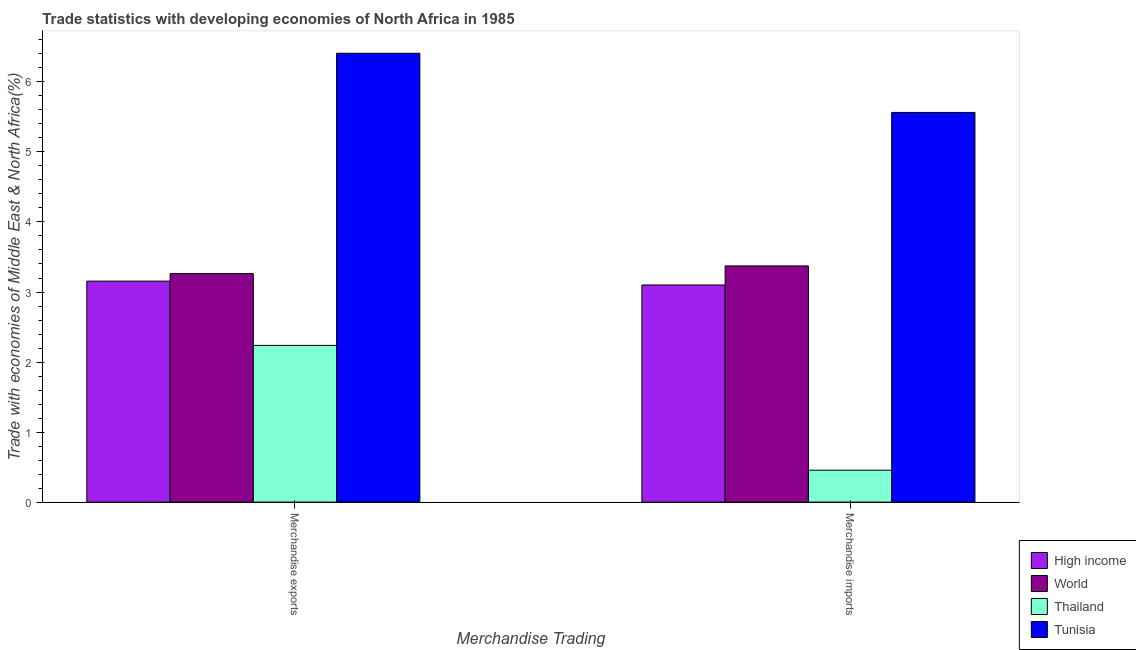Are the number of bars per tick equal to the number of legend labels?
Provide a short and direct response. Yes. Are the number of bars on each tick of the X-axis equal?
Offer a terse response. Yes. How many bars are there on the 1st tick from the left?
Provide a short and direct response. 4. How many bars are there on the 2nd tick from the right?
Keep it short and to the point. 4. What is the merchandise exports in High income?
Make the answer very short. 3.16. Across all countries, what is the maximum merchandise exports?
Your response must be concise. 6.41. Across all countries, what is the minimum merchandise imports?
Provide a short and direct response. 0.46. In which country was the merchandise exports maximum?
Provide a succinct answer. Tunisia. In which country was the merchandise imports minimum?
Make the answer very short. Thailand. What is the total merchandise imports in the graph?
Offer a terse response. 12.49. What is the difference between the merchandise exports in Thailand and that in Tunisia?
Your answer should be very brief. -4.17. What is the difference between the merchandise exports in Thailand and the merchandise imports in High income?
Ensure brevity in your answer.  -0.86. What is the average merchandise exports per country?
Provide a succinct answer. 3.77. What is the difference between the merchandise exports and merchandise imports in World?
Give a very brief answer. -0.11. What is the ratio of the merchandise exports in World to that in Tunisia?
Ensure brevity in your answer.  0.51. Is the merchandise exports in Tunisia less than that in High income?
Your answer should be very brief. No. What does the 1st bar from the right in Merchandise imports represents?
Keep it short and to the point. Tunisia. How many bars are there?
Make the answer very short. 8. How many countries are there in the graph?
Provide a succinct answer. 4. Does the graph contain any zero values?
Make the answer very short. No. How many legend labels are there?
Offer a terse response. 4. How are the legend labels stacked?
Offer a terse response. Vertical. What is the title of the graph?
Offer a very short reply. Trade statistics with developing economies of North Africa in 1985. Does "Gabon" appear as one of the legend labels in the graph?
Your answer should be compact. No. What is the label or title of the X-axis?
Keep it short and to the point. Merchandise Trading. What is the label or title of the Y-axis?
Your answer should be very brief. Trade with economies of Middle East & North Africa(%). What is the Trade with economies of Middle East & North Africa(%) in High income in Merchandise exports?
Make the answer very short. 3.16. What is the Trade with economies of Middle East & North Africa(%) in World in Merchandise exports?
Ensure brevity in your answer.  3.26. What is the Trade with economies of Middle East & North Africa(%) in Thailand in Merchandise exports?
Your response must be concise. 2.24. What is the Trade with economies of Middle East & North Africa(%) in Tunisia in Merchandise exports?
Make the answer very short. 6.41. What is the Trade with economies of Middle East & North Africa(%) of High income in Merchandise imports?
Offer a terse response. 3.1. What is the Trade with economies of Middle East & North Africa(%) in World in Merchandise imports?
Ensure brevity in your answer.  3.37. What is the Trade with economies of Middle East & North Africa(%) in Thailand in Merchandise imports?
Make the answer very short. 0.46. What is the Trade with economies of Middle East & North Africa(%) in Tunisia in Merchandise imports?
Ensure brevity in your answer.  5.56. Across all Merchandise Trading, what is the maximum Trade with economies of Middle East & North Africa(%) in High income?
Your answer should be compact. 3.16. Across all Merchandise Trading, what is the maximum Trade with economies of Middle East & North Africa(%) in World?
Provide a succinct answer. 3.37. Across all Merchandise Trading, what is the maximum Trade with economies of Middle East & North Africa(%) in Thailand?
Your answer should be very brief. 2.24. Across all Merchandise Trading, what is the maximum Trade with economies of Middle East & North Africa(%) of Tunisia?
Your response must be concise. 6.41. Across all Merchandise Trading, what is the minimum Trade with economies of Middle East & North Africa(%) in High income?
Provide a short and direct response. 3.1. Across all Merchandise Trading, what is the minimum Trade with economies of Middle East & North Africa(%) in World?
Give a very brief answer. 3.26. Across all Merchandise Trading, what is the minimum Trade with economies of Middle East & North Africa(%) in Thailand?
Offer a very short reply. 0.46. Across all Merchandise Trading, what is the minimum Trade with economies of Middle East & North Africa(%) of Tunisia?
Your answer should be very brief. 5.56. What is the total Trade with economies of Middle East & North Africa(%) in High income in the graph?
Your answer should be very brief. 6.26. What is the total Trade with economies of Middle East & North Africa(%) of World in the graph?
Offer a terse response. 6.64. What is the total Trade with economies of Middle East & North Africa(%) of Thailand in the graph?
Provide a succinct answer. 2.69. What is the total Trade with economies of Middle East & North Africa(%) of Tunisia in the graph?
Your answer should be compact. 11.97. What is the difference between the Trade with economies of Middle East & North Africa(%) of High income in Merchandise exports and that in Merchandise imports?
Provide a short and direct response. 0.05. What is the difference between the Trade with economies of Middle East & North Africa(%) of World in Merchandise exports and that in Merchandise imports?
Your response must be concise. -0.11. What is the difference between the Trade with economies of Middle East & North Africa(%) of Thailand in Merchandise exports and that in Merchandise imports?
Your response must be concise. 1.78. What is the difference between the Trade with economies of Middle East & North Africa(%) in Tunisia in Merchandise exports and that in Merchandise imports?
Give a very brief answer. 0.84. What is the difference between the Trade with economies of Middle East & North Africa(%) in High income in Merchandise exports and the Trade with economies of Middle East & North Africa(%) in World in Merchandise imports?
Give a very brief answer. -0.22. What is the difference between the Trade with economies of Middle East & North Africa(%) of High income in Merchandise exports and the Trade with economies of Middle East & North Africa(%) of Thailand in Merchandise imports?
Offer a very short reply. 2.7. What is the difference between the Trade with economies of Middle East & North Africa(%) in High income in Merchandise exports and the Trade with economies of Middle East & North Africa(%) in Tunisia in Merchandise imports?
Your response must be concise. -2.41. What is the difference between the Trade with economies of Middle East & North Africa(%) of World in Merchandise exports and the Trade with economies of Middle East & North Africa(%) of Thailand in Merchandise imports?
Ensure brevity in your answer.  2.81. What is the difference between the Trade with economies of Middle East & North Africa(%) of World in Merchandise exports and the Trade with economies of Middle East & North Africa(%) of Tunisia in Merchandise imports?
Keep it short and to the point. -2.3. What is the difference between the Trade with economies of Middle East & North Africa(%) of Thailand in Merchandise exports and the Trade with economies of Middle East & North Africa(%) of Tunisia in Merchandise imports?
Offer a very short reply. -3.33. What is the average Trade with economies of Middle East & North Africa(%) of High income per Merchandise Trading?
Provide a succinct answer. 3.13. What is the average Trade with economies of Middle East & North Africa(%) in World per Merchandise Trading?
Your response must be concise. 3.32. What is the average Trade with economies of Middle East & North Africa(%) of Thailand per Merchandise Trading?
Give a very brief answer. 1.35. What is the average Trade with economies of Middle East & North Africa(%) of Tunisia per Merchandise Trading?
Make the answer very short. 5.99. What is the difference between the Trade with economies of Middle East & North Africa(%) of High income and Trade with economies of Middle East & North Africa(%) of World in Merchandise exports?
Keep it short and to the point. -0.11. What is the difference between the Trade with economies of Middle East & North Africa(%) of High income and Trade with economies of Middle East & North Africa(%) of Thailand in Merchandise exports?
Provide a succinct answer. 0.92. What is the difference between the Trade with economies of Middle East & North Africa(%) of High income and Trade with economies of Middle East & North Africa(%) of Tunisia in Merchandise exports?
Your answer should be compact. -3.25. What is the difference between the Trade with economies of Middle East & North Africa(%) in World and Trade with economies of Middle East & North Africa(%) in Thailand in Merchandise exports?
Offer a terse response. 1.02. What is the difference between the Trade with economies of Middle East & North Africa(%) of World and Trade with economies of Middle East & North Africa(%) of Tunisia in Merchandise exports?
Ensure brevity in your answer.  -3.15. What is the difference between the Trade with economies of Middle East & North Africa(%) in Thailand and Trade with economies of Middle East & North Africa(%) in Tunisia in Merchandise exports?
Provide a short and direct response. -4.17. What is the difference between the Trade with economies of Middle East & North Africa(%) of High income and Trade with economies of Middle East & North Africa(%) of World in Merchandise imports?
Make the answer very short. -0.27. What is the difference between the Trade with economies of Middle East & North Africa(%) of High income and Trade with economies of Middle East & North Africa(%) of Thailand in Merchandise imports?
Your answer should be very brief. 2.64. What is the difference between the Trade with economies of Middle East & North Africa(%) in High income and Trade with economies of Middle East & North Africa(%) in Tunisia in Merchandise imports?
Provide a succinct answer. -2.46. What is the difference between the Trade with economies of Middle East & North Africa(%) in World and Trade with economies of Middle East & North Africa(%) in Thailand in Merchandise imports?
Offer a very short reply. 2.92. What is the difference between the Trade with economies of Middle East & North Africa(%) of World and Trade with economies of Middle East & North Africa(%) of Tunisia in Merchandise imports?
Offer a very short reply. -2.19. What is the difference between the Trade with economies of Middle East & North Africa(%) in Thailand and Trade with economies of Middle East & North Africa(%) in Tunisia in Merchandise imports?
Provide a short and direct response. -5.11. What is the ratio of the Trade with economies of Middle East & North Africa(%) in High income in Merchandise exports to that in Merchandise imports?
Make the answer very short. 1.02. What is the ratio of the Trade with economies of Middle East & North Africa(%) of World in Merchandise exports to that in Merchandise imports?
Provide a succinct answer. 0.97. What is the ratio of the Trade with economies of Middle East & North Africa(%) of Thailand in Merchandise exports to that in Merchandise imports?
Make the answer very short. 4.91. What is the ratio of the Trade with economies of Middle East & North Africa(%) of Tunisia in Merchandise exports to that in Merchandise imports?
Offer a very short reply. 1.15. What is the difference between the highest and the second highest Trade with economies of Middle East & North Africa(%) in High income?
Provide a succinct answer. 0.05. What is the difference between the highest and the second highest Trade with economies of Middle East & North Africa(%) of World?
Offer a terse response. 0.11. What is the difference between the highest and the second highest Trade with economies of Middle East & North Africa(%) of Thailand?
Ensure brevity in your answer.  1.78. What is the difference between the highest and the second highest Trade with economies of Middle East & North Africa(%) in Tunisia?
Make the answer very short. 0.84. What is the difference between the highest and the lowest Trade with economies of Middle East & North Africa(%) in High income?
Keep it short and to the point. 0.05. What is the difference between the highest and the lowest Trade with economies of Middle East & North Africa(%) in World?
Keep it short and to the point. 0.11. What is the difference between the highest and the lowest Trade with economies of Middle East & North Africa(%) of Thailand?
Make the answer very short. 1.78. What is the difference between the highest and the lowest Trade with economies of Middle East & North Africa(%) of Tunisia?
Your answer should be very brief. 0.84. 